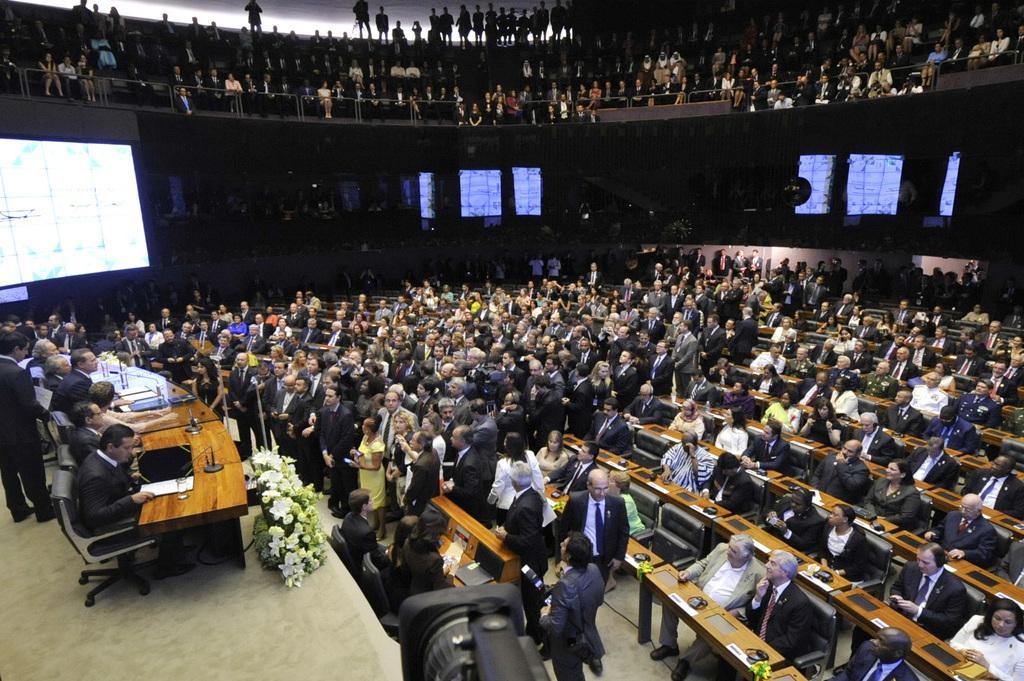Describe this image in one or two sentences. In this image we can see a conference hall where so many people are sitting and standing. We can see one table and screen on the left side of the image. There is a camera at the bottom of the image. We can see flowers on the stage. 